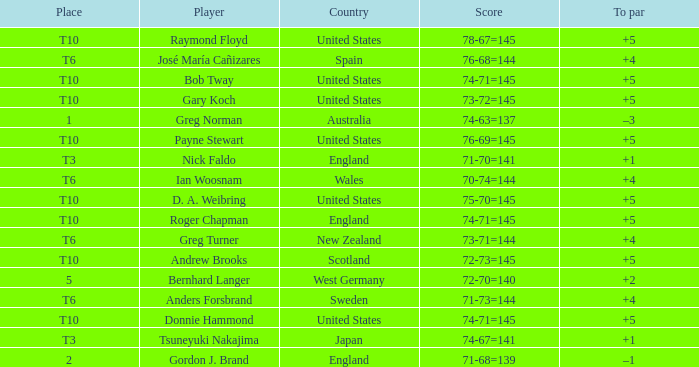Which player scored 76-68=144? José María Cañizares. 